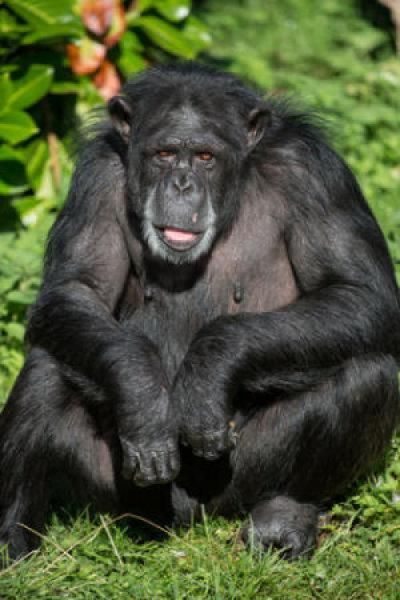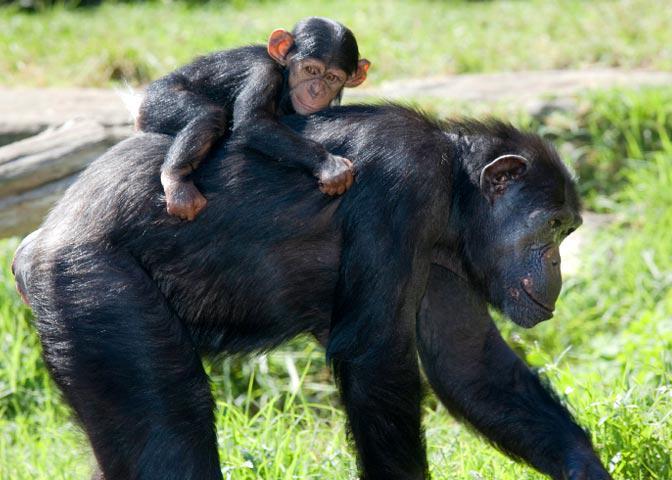The first image is the image on the left, the second image is the image on the right. Assess this claim about the two images: "There are two monkeys in the image on the right.". Correct or not? Answer yes or no. Yes. 